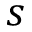<formula> <loc_0><loc_0><loc_500><loc_500>s</formula> 